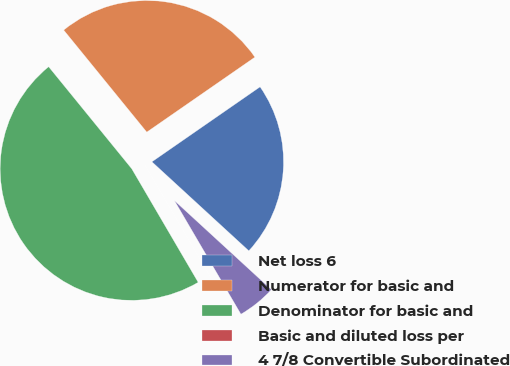<chart> <loc_0><loc_0><loc_500><loc_500><pie_chart><fcel>Net loss 6<fcel>Numerator for basic and<fcel>Denominator for basic and<fcel>Basic and diluted loss per<fcel>4 7/8 Convertible Subordinated<nl><fcel>21.47%<fcel>26.23%<fcel>47.55%<fcel>0.0%<fcel>4.75%<nl></chart> 